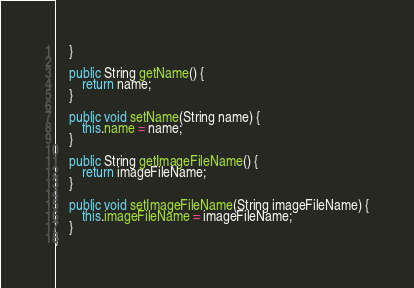Convert code to text. <code><loc_0><loc_0><loc_500><loc_500><_Java_>    }
    
    public String getName() {
        return name;
    }
    
    public void setName(String name) {
        this.name = name;
    }

    public String getImageFileName() {
        return imageFileName;
    }

    public void setImageFileName(String imageFileName) {
        this.imageFileName = imageFileName;
    }
}
</code> 